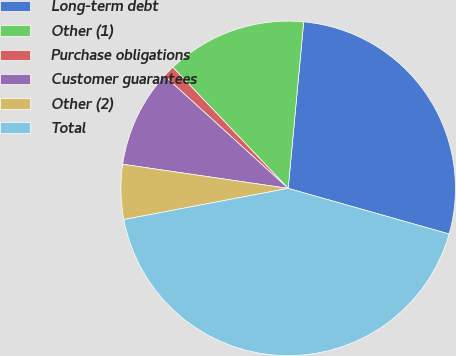Convert chart to OTSL. <chart><loc_0><loc_0><loc_500><loc_500><pie_chart><fcel>Long-term debt<fcel>Other (1)<fcel>Purchase obligations<fcel>Customer guarantees<fcel>Other (2)<fcel>Total<nl><fcel>27.92%<fcel>13.59%<fcel>1.14%<fcel>9.44%<fcel>5.29%<fcel>42.62%<nl></chart> 